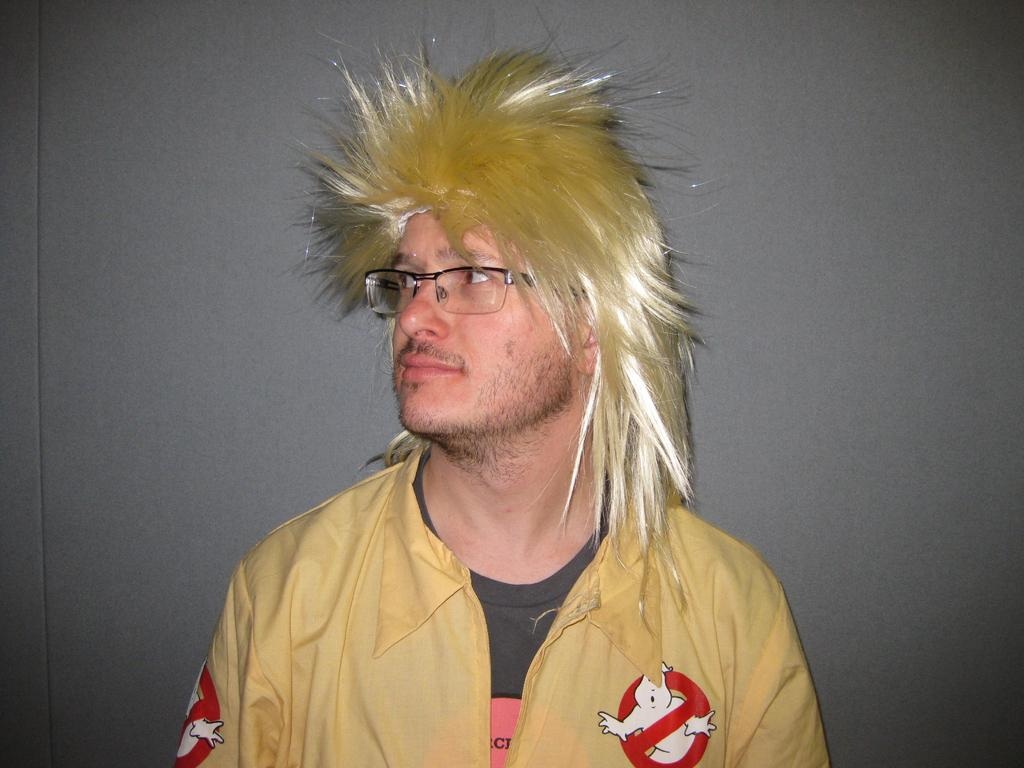What is the main subject of the image? The main subject of the image is a man. Can you describe the man's appearance in the image? The man is wearing a hair wig, specs, a black color t-shirt, and a yellow color jacket. What type of plant is the man watering in the image? There is no plant present in the image, and the man is not watering anything. What drug is the man taking in the image? There is no indication of the man taking any drug in the image. 